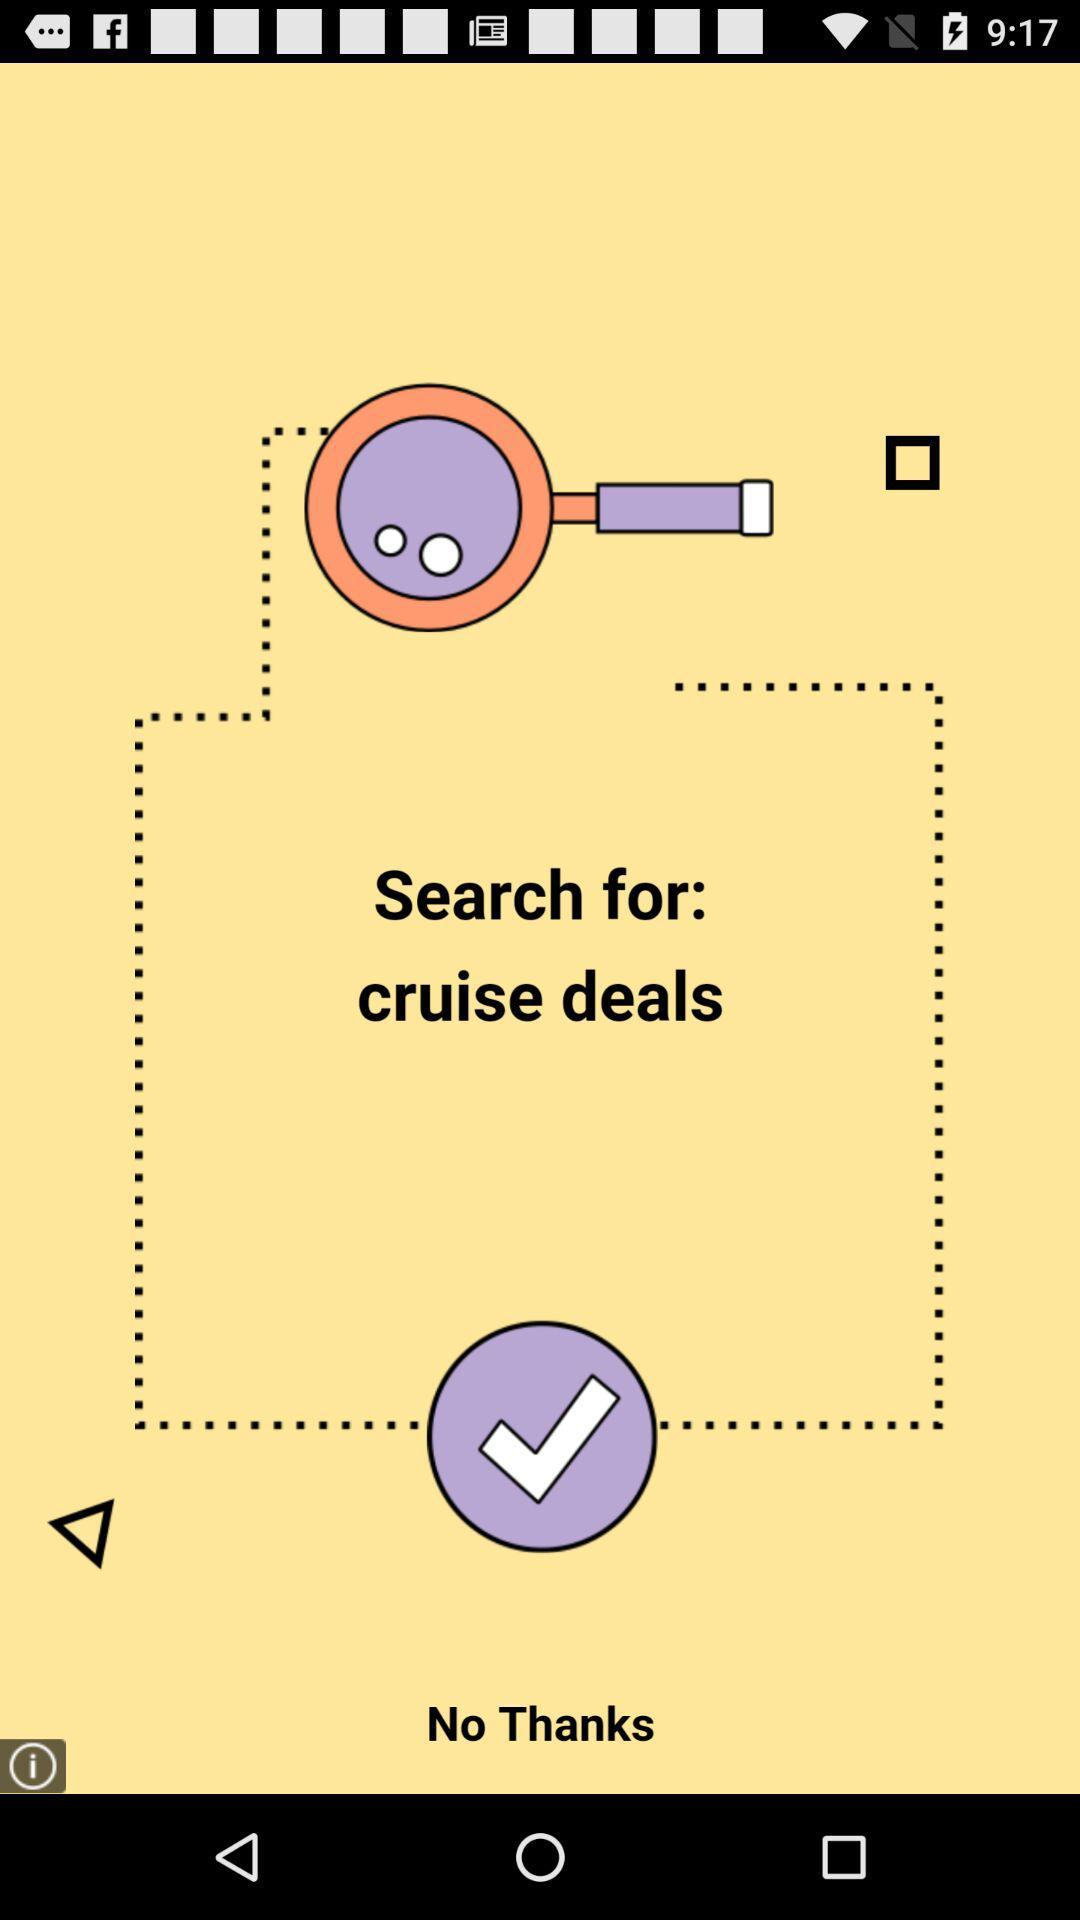What are the new features of the app?
When the provided information is insufficient, respond with <no answer>. <no answer> 